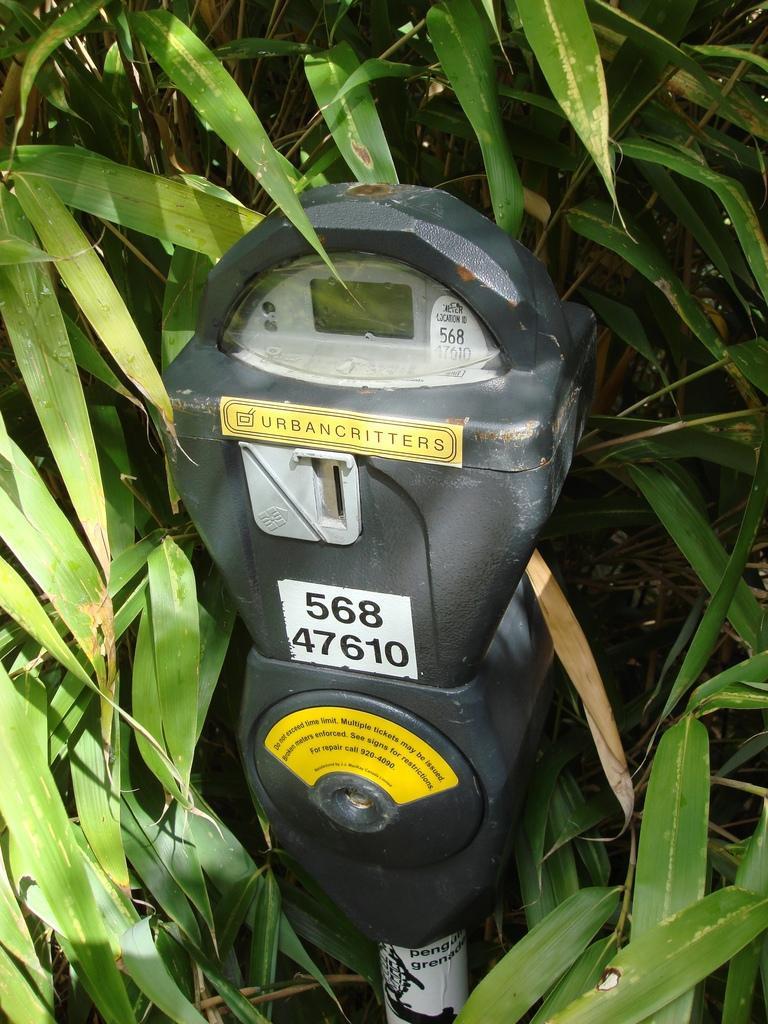<image>
Render a clear and concise summary of the photo. A parking meter with an urbancritters sticker on it stands in front of some plants. 